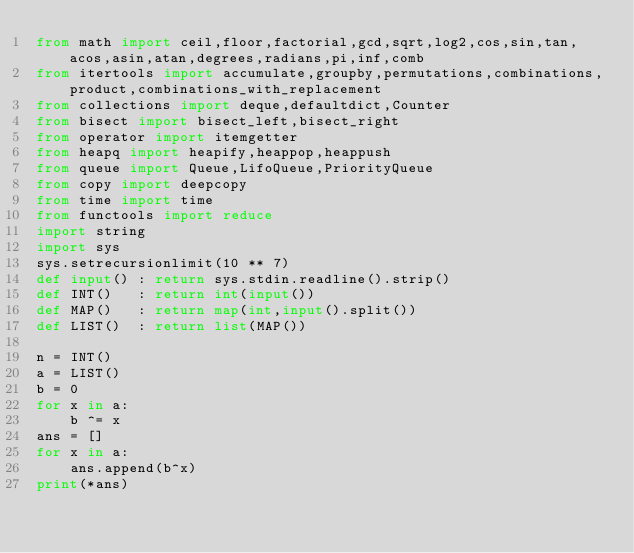Convert code to text. <code><loc_0><loc_0><loc_500><loc_500><_Python_>from math import ceil,floor,factorial,gcd,sqrt,log2,cos,sin,tan,acos,asin,atan,degrees,radians,pi,inf,comb
from itertools import accumulate,groupby,permutations,combinations,product,combinations_with_replacement
from collections import deque,defaultdict,Counter
from bisect import bisect_left,bisect_right
from operator import itemgetter
from heapq import heapify,heappop,heappush
from queue import Queue,LifoQueue,PriorityQueue
from copy import deepcopy
from time import time
from functools import reduce
import string
import sys
sys.setrecursionlimit(10 ** 7)
def input() : return sys.stdin.readline().strip()
def INT()   : return int(input())
def MAP()   : return map(int,input().split())
def LIST()  : return list(MAP())

n = INT()
a = LIST()
b = 0
for x in a:
    b ^= x
ans = []
for x in a:
    ans.append(b^x)
print(*ans)</code> 